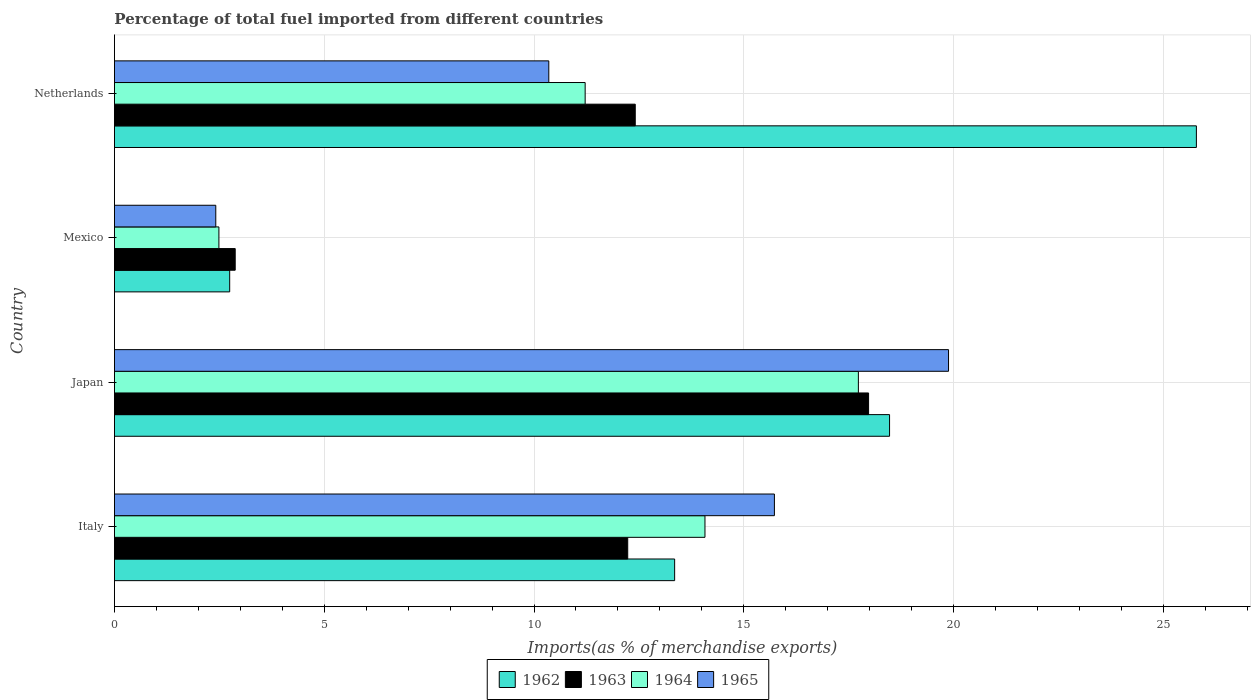How many different coloured bars are there?
Your answer should be very brief. 4. Are the number of bars on each tick of the Y-axis equal?
Offer a terse response. Yes. In how many cases, is the number of bars for a given country not equal to the number of legend labels?
Offer a very short reply. 0. What is the percentage of imports to different countries in 1965 in Netherlands?
Your response must be concise. 10.35. Across all countries, what is the maximum percentage of imports to different countries in 1962?
Provide a short and direct response. 25.79. Across all countries, what is the minimum percentage of imports to different countries in 1964?
Your response must be concise. 2.49. In which country was the percentage of imports to different countries in 1962 minimum?
Provide a short and direct response. Mexico. What is the total percentage of imports to different countries in 1963 in the graph?
Offer a very short reply. 45.5. What is the difference between the percentage of imports to different countries in 1963 in Japan and that in Netherlands?
Keep it short and to the point. 5.56. What is the difference between the percentage of imports to different countries in 1965 in Japan and the percentage of imports to different countries in 1963 in Italy?
Offer a very short reply. 7.65. What is the average percentage of imports to different countries in 1965 per country?
Provide a short and direct response. 12.09. What is the difference between the percentage of imports to different countries in 1965 and percentage of imports to different countries in 1963 in Netherlands?
Offer a very short reply. -2.06. What is the ratio of the percentage of imports to different countries in 1962 in Japan to that in Netherlands?
Offer a terse response. 0.72. Is the difference between the percentage of imports to different countries in 1965 in Italy and Japan greater than the difference between the percentage of imports to different countries in 1963 in Italy and Japan?
Ensure brevity in your answer.  Yes. What is the difference between the highest and the second highest percentage of imports to different countries in 1963?
Your answer should be compact. 5.56. What is the difference between the highest and the lowest percentage of imports to different countries in 1963?
Your answer should be compact. 15.1. Is the sum of the percentage of imports to different countries in 1965 in Japan and Netherlands greater than the maximum percentage of imports to different countries in 1962 across all countries?
Make the answer very short. Yes. Is it the case that in every country, the sum of the percentage of imports to different countries in 1963 and percentage of imports to different countries in 1965 is greater than the sum of percentage of imports to different countries in 1964 and percentage of imports to different countries in 1962?
Your answer should be compact. No. What does the 1st bar from the top in Japan represents?
Give a very brief answer. 1965. What does the 3rd bar from the bottom in Italy represents?
Your answer should be very brief. 1964. Is it the case that in every country, the sum of the percentage of imports to different countries in 1962 and percentage of imports to different countries in 1965 is greater than the percentage of imports to different countries in 1963?
Your response must be concise. Yes. How many bars are there?
Your answer should be very brief. 16. Are all the bars in the graph horizontal?
Offer a terse response. Yes. Does the graph contain any zero values?
Give a very brief answer. No. What is the title of the graph?
Ensure brevity in your answer.  Percentage of total fuel imported from different countries. What is the label or title of the X-axis?
Offer a terse response. Imports(as % of merchandise exports). What is the Imports(as % of merchandise exports) in 1962 in Italy?
Keep it short and to the point. 13.35. What is the Imports(as % of merchandise exports) in 1963 in Italy?
Keep it short and to the point. 12.23. What is the Imports(as % of merchandise exports) in 1964 in Italy?
Give a very brief answer. 14.07. What is the Imports(as % of merchandise exports) in 1965 in Italy?
Keep it short and to the point. 15.73. What is the Imports(as % of merchandise exports) of 1962 in Japan?
Give a very brief answer. 18.47. What is the Imports(as % of merchandise exports) in 1963 in Japan?
Keep it short and to the point. 17.97. What is the Imports(as % of merchandise exports) in 1964 in Japan?
Give a very brief answer. 17.73. What is the Imports(as % of merchandise exports) of 1965 in Japan?
Your answer should be very brief. 19.88. What is the Imports(as % of merchandise exports) of 1962 in Mexico?
Your answer should be compact. 2.75. What is the Imports(as % of merchandise exports) in 1963 in Mexico?
Your response must be concise. 2.88. What is the Imports(as % of merchandise exports) in 1964 in Mexico?
Provide a short and direct response. 2.49. What is the Imports(as % of merchandise exports) of 1965 in Mexico?
Make the answer very short. 2.42. What is the Imports(as % of merchandise exports) in 1962 in Netherlands?
Provide a short and direct response. 25.79. What is the Imports(as % of merchandise exports) in 1963 in Netherlands?
Give a very brief answer. 12.41. What is the Imports(as % of merchandise exports) of 1964 in Netherlands?
Keep it short and to the point. 11.22. What is the Imports(as % of merchandise exports) of 1965 in Netherlands?
Ensure brevity in your answer.  10.35. Across all countries, what is the maximum Imports(as % of merchandise exports) of 1962?
Your response must be concise. 25.79. Across all countries, what is the maximum Imports(as % of merchandise exports) of 1963?
Your answer should be very brief. 17.97. Across all countries, what is the maximum Imports(as % of merchandise exports) in 1964?
Make the answer very short. 17.73. Across all countries, what is the maximum Imports(as % of merchandise exports) in 1965?
Provide a short and direct response. 19.88. Across all countries, what is the minimum Imports(as % of merchandise exports) of 1962?
Provide a succinct answer. 2.75. Across all countries, what is the minimum Imports(as % of merchandise exports) of 1963?
Your answer should be very brief. 2.88. Across all countries, what is the minimum Imports(as % of merchandise exports) of 1964?
Your response must be concise. 2.49. Across all countries, what is the minimum Imports(as % of merchandise exports) in 1965?
Your answer should be compact. 2.42. What is the total Imports(as % of merchandise exports) in 1962 in the graph?
Provide a short and direct response. 60.36. What is the total Imports(as % of merchandise exports) of 1963 in the graph?
Ensure brevity in your answer.  45.5. What is the total Imports(as % of merchandise exports) of 1964 in the graph?
Ensure brevity in your answer.  45.52. What is the total Imports(as % of merchandise exports) of 1965 in the graph?
Your answer should be compact. 48.38. What is the difference between the Imports(as % of merchandise exports) of 1962 in Italy and that in Japan?
Your answer should be very brief. -5.12. What is the difference between the Imports(as % of merchandise exports) in 1963 in Italy and that in Japan?
Provide a succinct answer. -5.74. What is the difference between the Imports(as % of merchandise exports) of 1964 in Italy and that in Japan?
Provide a short and direct response. -3.66. What is the difference between the Imports(as % of merchandise exports) of 1965 in Italy and that in Japan?
Offer a very short reply. -4.15. What is the difference between the Imports(as % of merchandise exports) in 1962 in Italy and that in Mexico?
Your answer should be compact. 10.61. What is the difference between the Imports(as % of merchandise exports) of 1963 in Italy and that in Mexico?
Your answer should be very brief. 9.36. What is the difference between the Imports(as % of merchandise exports) in 1964 in Italy and that in Mexico?
Ensure brevity in your answer.  11.58. What is the difference between the Imports(as % of merchandise exports) in 1965 in Italy and that in Mexico?
Your response must be concise. 13.31. What is the difference between the Imports(as % of merchandise exports) of 1962 in Italy and that in Netherlands?
Provide a succinct answer. -12.44. What is the difference between the Imports(as % of merchandise exports) of 1963 in Italy and that in Netherlands?
Offer a very short reply. -0.18. What is the difference between the Imports(as % of merchandise exports) of 1964 in Italy and that in Netherlands?
Your answer should be very brief. 2.86. What is the difference between the Imports(as % of merchandise exports) of 1965 in Italy and that in Netherlands?
Provide a short and direct response. 5.38. What is the difference between the Imports(as % of merchandise exports) of 1962 in Japan and that in Mexico?
Offer a terse response. 15.73. What is the difference between the Imports(as % of merchandise exports) in 1963 in Japan and that in Mexico?
Your answer should be compact. 15.1. What is the difference between the Imports(as % of merchandise exports) of 1964 in Japan and that in Mexico?
Keep it short and to the point. 15.24. What is the difference between the Imports(as % of merchandise exports) of 1965 in Japan and that in Mexico?
Your response must be concise. 17.46. What is the difference between the Imports(as % of merchandise exports) of 1962 in Japan and that in Netherlands?
Your answer should be compact. -7.31. What is the difference between the Imports(as % of merchandise exports) of 1963 in Japan and that in Netherlands?
Provide a short and direct response. 5.56. What is the difference between the Imports(as % of merchandise exports) of 1964 in Japan and that in Netherlands?
Offer a very short reply. 6.51. What is the difference between the Imports(as % of merchandise exports) in 1965 in Japan and that in Netherlands?
Offer a very short reply. 9.53. What is the difference between the Imports(as % of merchandise exports) of 1962 in Mexico and that in Netherlands?
Provide a short and direct response. -23.04. What is the difference between the Imports(as % of merchandise exports) of 1963 in Mexico and that in Netherlands?
Give a very brief answer. -9.53. What is the difference between the Imports(as % of merchandise exports) in 1964 in Mexico and that in Netherlands?
Offer a terse response. -8.73. What is the difference between the Imports(as % of merchandise exports) of 1965 in Mexico and that in Netherlands?
Provide a short and direct response. -7.94. What is the difference between the Imports(as % of merchandise exports) of 1962 in Italy and the Imports(as % of merchandise exports) of 1963 in Japan?
Provide a succinct answer. -4.62. What is the difference between the Imports(as % of merchandise exports) of 1962 in Italy and the Imports(as % of merchandise exports) of 1964 in Japan?
Offer a very short reply. -4.38. What is the difference between the Imports(as % of merchandise exports) of 1962 in Italy and the Imports(as % of merchandise exports) of 1965 in Japan?
Keep it short and to the point. -6.53. What is the difference between the Imports(as % of merchandise exports) of 1963 in Italy and the Imports(as % of merchandise exports) of 1964 in Japan?
Give a very brief answer. -5.5. What is the difference between the Imports(as % of merchandise exports) in 1963 in Italy and the Imports(as % of merchandise exports) in 1965 in Japan?
Your answer should be very brief. -7.65. What is the difference between the Imports(as % of merchandise exports) of 1964 in Italy and the Imports(as % of merchandise exports) of 1965 in Japan?
Ensure brevity in your answer.  -5.8. What is the difference between the Imports(as % of merchandise exports) of 1962 in Italy and the Imports(as % of merchandise exports) of 1963 in Mexico?
Your response must be concise. 10.47. What is the difference between the Imports(as % of merchandise exports) of 1962 in Italy and the Imports(as % of merchandise exports) of 1964 in Mexico?
Offer a very short reply. 10.86. What is the difference between the Imports(as % of merchandise exports) in 1962 in Italy and the Imports(as % of merchandise exports) in 1965 in Mexico?
Ensure brevity in your answer.  10.94. What is the difference between the Imports(as % of merchandise exports) of 1963 in Italy and the Imports(as % of merchandise exports) of 1964 in Mexico?
Keep it short and to the point. 9.74. What is the difference between the Imports(as % of merchandise exports) of 1963 in Italy and the Imports(as % of merchandise exports) of 1965 in Mexico?
Your answer should be very brief. 9.82. What is the difference between the Imports(as % of merchandise exports) in 1964 in Italy and the Imports(as % of merchandise exports) in 1965 in Mexico?
Give a very brief answer. 11.66. What is the difference between the Imports(as % of merchandise exports) in 1962 in Italy and the Imports(as % of merchandise exports) in 1963 in Netherlands?
Offer a terse response. 0.94. What is the difference between the Imports(as % of merchandise exports) of 1962 in Italy and the Imports(as % of merchandise exports) of 1964 in Netherlands?
Your response must be concise. 2.13. What is the difference between the Imports(as % of merchandise exports) of 1962 in Italy and the Imports(as % of merchandise exports) of 1965 in Netherlands?
Your answer should be compact. 3. What is the difference between the Imports(as % of merchandise exports) in 1963 in Italy and the Imports(as % of merchandise exports) in 1964 in Netherlands?
Provide a succinct answer. 1.01. What is the difference between the Imports(as % of merchandise exports) in 1963 in Italy and the Imports(as % of merchandise exports) in 1965 in Netherlands?
Your response must be concise. 1.88. What is the difference between the Imports(as % of merchandise exports) of 1964 in Italy and the Imports(as % of merchandise exports) of 1965 in Netherlands?
Ensure brevity in your answer.  3.72. What is the difference between the Imports(as % of merchandise exports) in 1962 in Japan and the Imports(as % of merchandise exports) in 1963 in Mexico?
Give a very brief answer. 15.6. What is the difference between the Imports(as % of merchandise exports) in 1962 in Japan and the Imports(as % of merchandise exports) in 1964 in Mexico?
Offer a terse response. 15.98. What is the difference between the Imports(as % of merchandise exports) in 1962 in Japan and the Imports(as % of merchandise exports) in 1965 in Mexico?
Provide a succinct answer. 16.06. What is the difference between the Imports(as % of merchandise exports) of 1963 in Japan and the Imports(as % of merchandise exports) of 1964 in Mexico?
Your answer should be very brief. 15.48. What is the difference between the Imports(as % of merchandise exports) in 1963 in Japan and the Imports(as % of merchandise exports) in 1965 in Mexico?
Provide a short and direct response. 15.56. What is the difference between the Imports(as % of merchandise exports) in 1964 in Japan and the Imports(as % of merchandise exports) in 1965 in Mexico?
Your answer should be very brief. 15.32. What is the difference between the Imports(as % of merchandise exports) of 1962 in Japan and the Imports(as % of merchandise exports) of 1963 in Netherlands?
Give a very brief answer. 6.06. What is the difference between the Imports(as % of merchandise exports) in 1962 in Japan and the Imports(as % of merchandise exports) in 1964 in Netherlands?
Keep it short and to the point. 7.25. What is the difference between the Imports(as % of merchandise exports) in 1962 in Japan and the Imports(as % of merchandise exports) in 1965 in Netherlands?
Offer a terse response. 8.12. What is the difference between the Imports(as % of merchandise exports) in 1963 in Japan and the Imports(as % of merchandise exports) in 1964 in Netherlands?
Keep it short and to the point. 6.76. What is the difference between the Imports(as % of merchandise exports) in 1963 in Japan and the Imports(as % of merchandise exports) in 1965 in Netherlands?
Your answer should be compact. 7.62. What is the difference between the Imports(as % of merchandise exports) of 1964 in Japan and the Imports(as % of merchandise exports) of 1965 in Netherlands?
Ensure brevity in your answer.  7.38. What is the difference between the Imports(as % of merchandise exports) of 1962 in Mexico and the Imports(as % of merchandise exports) of 1963 in Netherlands?
Provide a succinct answer. -9.67. What is the difference between the Imports(as % of merchandise exports) of 1962 in Mexico and the Imports(as % of merchandise exports) of 1964 in Netherlands?
Your answer should be very brief. -8.47. What is the difference between the Imports(as % of merchandise exports) of 1962 in Mexico and the Imports(as % of merchandise exports) of 1965 in Netherlands?
Give a very brief answer. -7.61. What is the difference between the Imports(as % of merchandise exports) in 1963 in Mexico and the Imports(as % of merchandise exports) in 1964 in Netherlands?
Ensure brevity in your answer.  -8.34. What is the difference between the Imports(as % of merchandise exports) in 1963 in Mexico and the Imports(as % of merchandise exports) in 1965 in Netherlands?
Provide a short and direct response. -7.47. What is the difference between the Imports(as % of merchandise exports) in 1964 in Mexico and the Imports(as % of merchandise exports) in 1965 in Netherlands?
Offer a very short reply. -7.86. What is the average Imports(as % of merchandise exports) in 1962 per country?
Give a very brief answer. 15.09. What is the average Imports(as % of merchandise exports) in 1963 per country?
Provide a succinct answer. 11.38. What is the average Imports(as % of merchandise exports) of 1964 per country?
Your answer should be compact. 11.38. What is the average Imports(as % of merchandise exports) of 1965 per country?
Offer a very short reply. 12.09. What is the difference between the Imports(as % of merchandise exports) in 1962 and Imports(as % of merchandise exports) in 1963 in Italy?
Ensure brevity in your answer.  1.12. What is the difference between the Imports(as % of merchandise exports) of 1962 and Imports(as % of merchandise exports) of 1964 in Italy?
Offer a very short reply. -0.72. What is the difference between the Imports(as % of merchandise exports) of 1962 and Imports(as % of merchandise exports) of 1965 in Italy?
Provide a short and direct response. -2.38. What is the difference between the Imports(as % of merchandise exports) of 1963 and Imports(as % of merchandise exports) of 1964 in Italy?
Make the answer very short. -1.84. What is the difference between the Imports(as % of merchandise exports) of 1963 and Imports(as % of merchandise exports) of 1965 in Italy?
Your answer should be compact. -3.5. What is the difference between the Imports(as % of merchandise exports) of 1964 and Imports(as % of merchandise exports) of 1965 in Italy?
Your answer should be compact. -1.65. What is the difference between the Imports(as % of merchandise exports) of 1962 and Imports(as % of merchandise exports) of 1964 in Japan?
Your response must be concise. 0.74. What is the difference between the Imports(as % of merchandise exports) of 1962 and Imports(as % of merchandise exports) of 1965 in Japan?
Provide a succinct answer. -1.41. What is the difference between the Imports(as % of merchandise exports) of 1963 and Imports(as % of merchandise exports) of 1964 in Japan?
Keep it short and to the point. 0.24. What is the difference between the Imports(as % of merchandise exports) in 1963 and Imports(as % of merchandise exports) in 1965 in Japan?
Make the answer very short. -1.91. What is the difference between the Imports(as % of merchandise exports) in 1964 and Imports(as % of merchandise exports) in 1965 in Japan?
Your response must be concise. -2.15. What is the difference between the Imports(as % of merchandise exports) of 1962 and Imports(as % of merchandise exports) of 1963 in Mexico?
Ensure brevity in your answer.  -0.13. What is the difference between the Imports(as % of merchandise exports) of 1962 and Imports(as % of merchandise exports) of 1964 in Mexico?
Give a very brief answer. 0.26. What is the difference between the Imports(as % of merchandise exports) in 1962 and Imports(as % of merchandise exports) in 1965 in Mexico?
Your answer should be very brief. 0.33. What is the difference between the Imports(as % of merchandise exports) in 1963 and Imports(as % of merchandise exports) in 1964 in Mexico?
Make the answer very short. 0.39. What is the difference between the Imports(as % of merchandise exports) of 1963 and Imports(as % of merchandise exports) of 1965 in Mexico?
Your answer should be very brief. 0.46. What is the difference between the Imports(as % of merchandise exports) of 1964 and Imports(as % of merchandise exports) of 1965 in Mexico?
Your answer should be very brief. 0.07. What is the difference between the Imports(as % of merchandise exports) in 1962 and Imports(as % of merchandise exports) in 1963 in Netherlands?
Your answer should be very brief. 13.37. What is the difference between the Imports(as % of merchandise exports) in 1962 and Imports(as % of merchandise exports) in 1964 in Netherlands?
Offer a very short reply. 14.57. What is the difference between the Imports(as % of merchandise exports) of 1962 and Imports(as % of merchandise exports) of 1965 in Netherlands?
Provide a short and direct response. 15.43. What is the difference between the Imports(as % of merchandise exports) of 1963 and Imports(as % of merchandise exports) of 1964 in Netherlands?
Keep it short and to the point. 1.19. What is the difference between the Imports(as % of merchandise exports) of 1963 and Imports(as % of merchandise exports) of 1965 in Netherlands?
Give a very brief answer. 2.06. What is the difference between the Imports(as % of merchandise exports) in 1964 and Imports(as % of merchandise exports) in 1965 in Netherlands?
Your answer should be very brief. 0.87. What is the ratio of the Imports(as % of merchandise exports) of 1962 in Italy to that in Japan?
Provide a succinct answer. 0.72. What is the ratio of the Imports(as % of merchandise exports) in 1963 in Italy to that in Japan?
Keep it short and to the point. 0.68. What is the ratio of the Imports(as % of merchandise exports) in 1964 in Italy to that in Japan?
Make the answer very short. 0.79. What is the ratio of the Imports(as % of merchandise exports) of 1965 in Italy to that in Japan?
Your response must be concise. 0.79. What is the ratio of the Imports(as % of merchandise exports) of 1962 in Italy to that in Mexico?
Give a very brief answer. 4.86. What is the ratio of the Imports(as % of merchandise exports) of 1963 in Italy to that in Mexico?
Offer a very short reply. 4.25. What is the ratio of the Imports(as % of merchandise exports) of 1964 in Italy to that in Mexico?
Your response must be concise. 5.65. What is the ratio of the Imports(as % of merchandise exports) in 1965 in Italy to that in Mexico?
Ensure brevity in your answer.  6.51. What is the ratio of the Imports(as % of merchandise exports) of 1962 in Italy to that in Netherlands?
Ensure brevity in your answer.  0.52. What is the ratio of the Imports(as % of merchandise exports) of 1963 in Italy to that in Netherlands?
Give a very brief answer. 0.99. What is the ratio of the Imports(as % of merchandise exports) of 1964 in Italy to that in Netherlands?
Offer a terse response. 1.25. What is the ratio of the Imports(as % of merchandise exports) in 1965 in Italy to that in Netherlands?
Give a very brief answer. 1.52. What is the ratio of the Imports(as % of merchandise exports) of 1962 in Japan to that in Mexico?
Your response must be concise. 6.72. What is the ratio of the Imports(as % of merchandise exports) of 1963 in Japan to that in Mexico?
Offer a very short reply. 6.24. What is the ratio of the Imports(as % of merchandise exports) in 1964 in Japan to that in Mexico?
Provide a succinct answer. 7.12. What is the ratio of the Imports(as % of merchandise exports) of 1965 in Japan to that in Mexico?
Your answer should be very brief. 8.23. What is the ratio of the Imports(as % of merchandise exports) in 1962 in Japan to that in Netherlands?
Ensure brevity in your answer.  0.72. What is the ratio of the Imports(as % of merchandise exports) in 1963 in Japan to that in Netherlands?
Ensure brevity in your answer.  1.45. What is the ratio of the Imports(as % of merchandise exports) of 1964 in Japan to that in Netherlands?
Provide a succinct answer. 1.58. What is the ratio of the Imports(as % of merchandise exports) in 1965 in Japan to that in Netherlands?
Give a very brief answer. 1.92. What is the ratio of the Imports(as % of merchandise exports) in 1962 in Mexico to that in Netherlands?
Ensure brevity in your answer.  0.11. What is the ratio of the Imports(as % of merchandise exports) of 1963 in Mexico to that in Netherlands?
Your answer should be very brief. 0.23. What is the ratio of the Imports(as % of merchandise exports) in 1964 in Mexico to that in Netherlands?
Provide a short and direct response. 0.22. What is the ratio of the Imports(as % of merchandise exports) of 1965 in Mexico to that in Netherlands?
Keep it short and to the point. 0.23. What is the difference between the highest and the second highest Imports(as % of merchandise exports) in 1962?
Provide a succinct answer. 7.31. What is the difference between the highest and the second highest Imports(as % of merchandise exports) in 1963?
Give a very brief answer. 5.56. What is the difference between the highest and the second highest Imports(as % of merchandise exports) in 1964?
Your response must be concise. 3.66. What is the difference between the highest and the second highest Imports(as % of merchandise exports) in 1965?
Provide a succinct answer. 4.15. What is the difference between the highest and the lowest Imports(as % of merchandise exports) of 1962?
Your response must be concise. 23.04. What is the difference between the highest and the lowest Imports(as % of merchandise exports) of 1963?
Give a very brief answer. 15.1. What is the difference between the highest and the lowest Imports(as % of merchandise exports) of 1964?
Ensure brevity in your answer.  15.24. What is the difference between the highest and the lowest Imports(as % of merchandise exports) in 1965?
Provide a succinct answer. 17.46. 